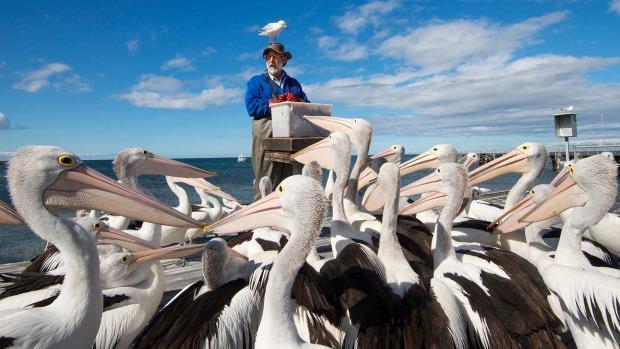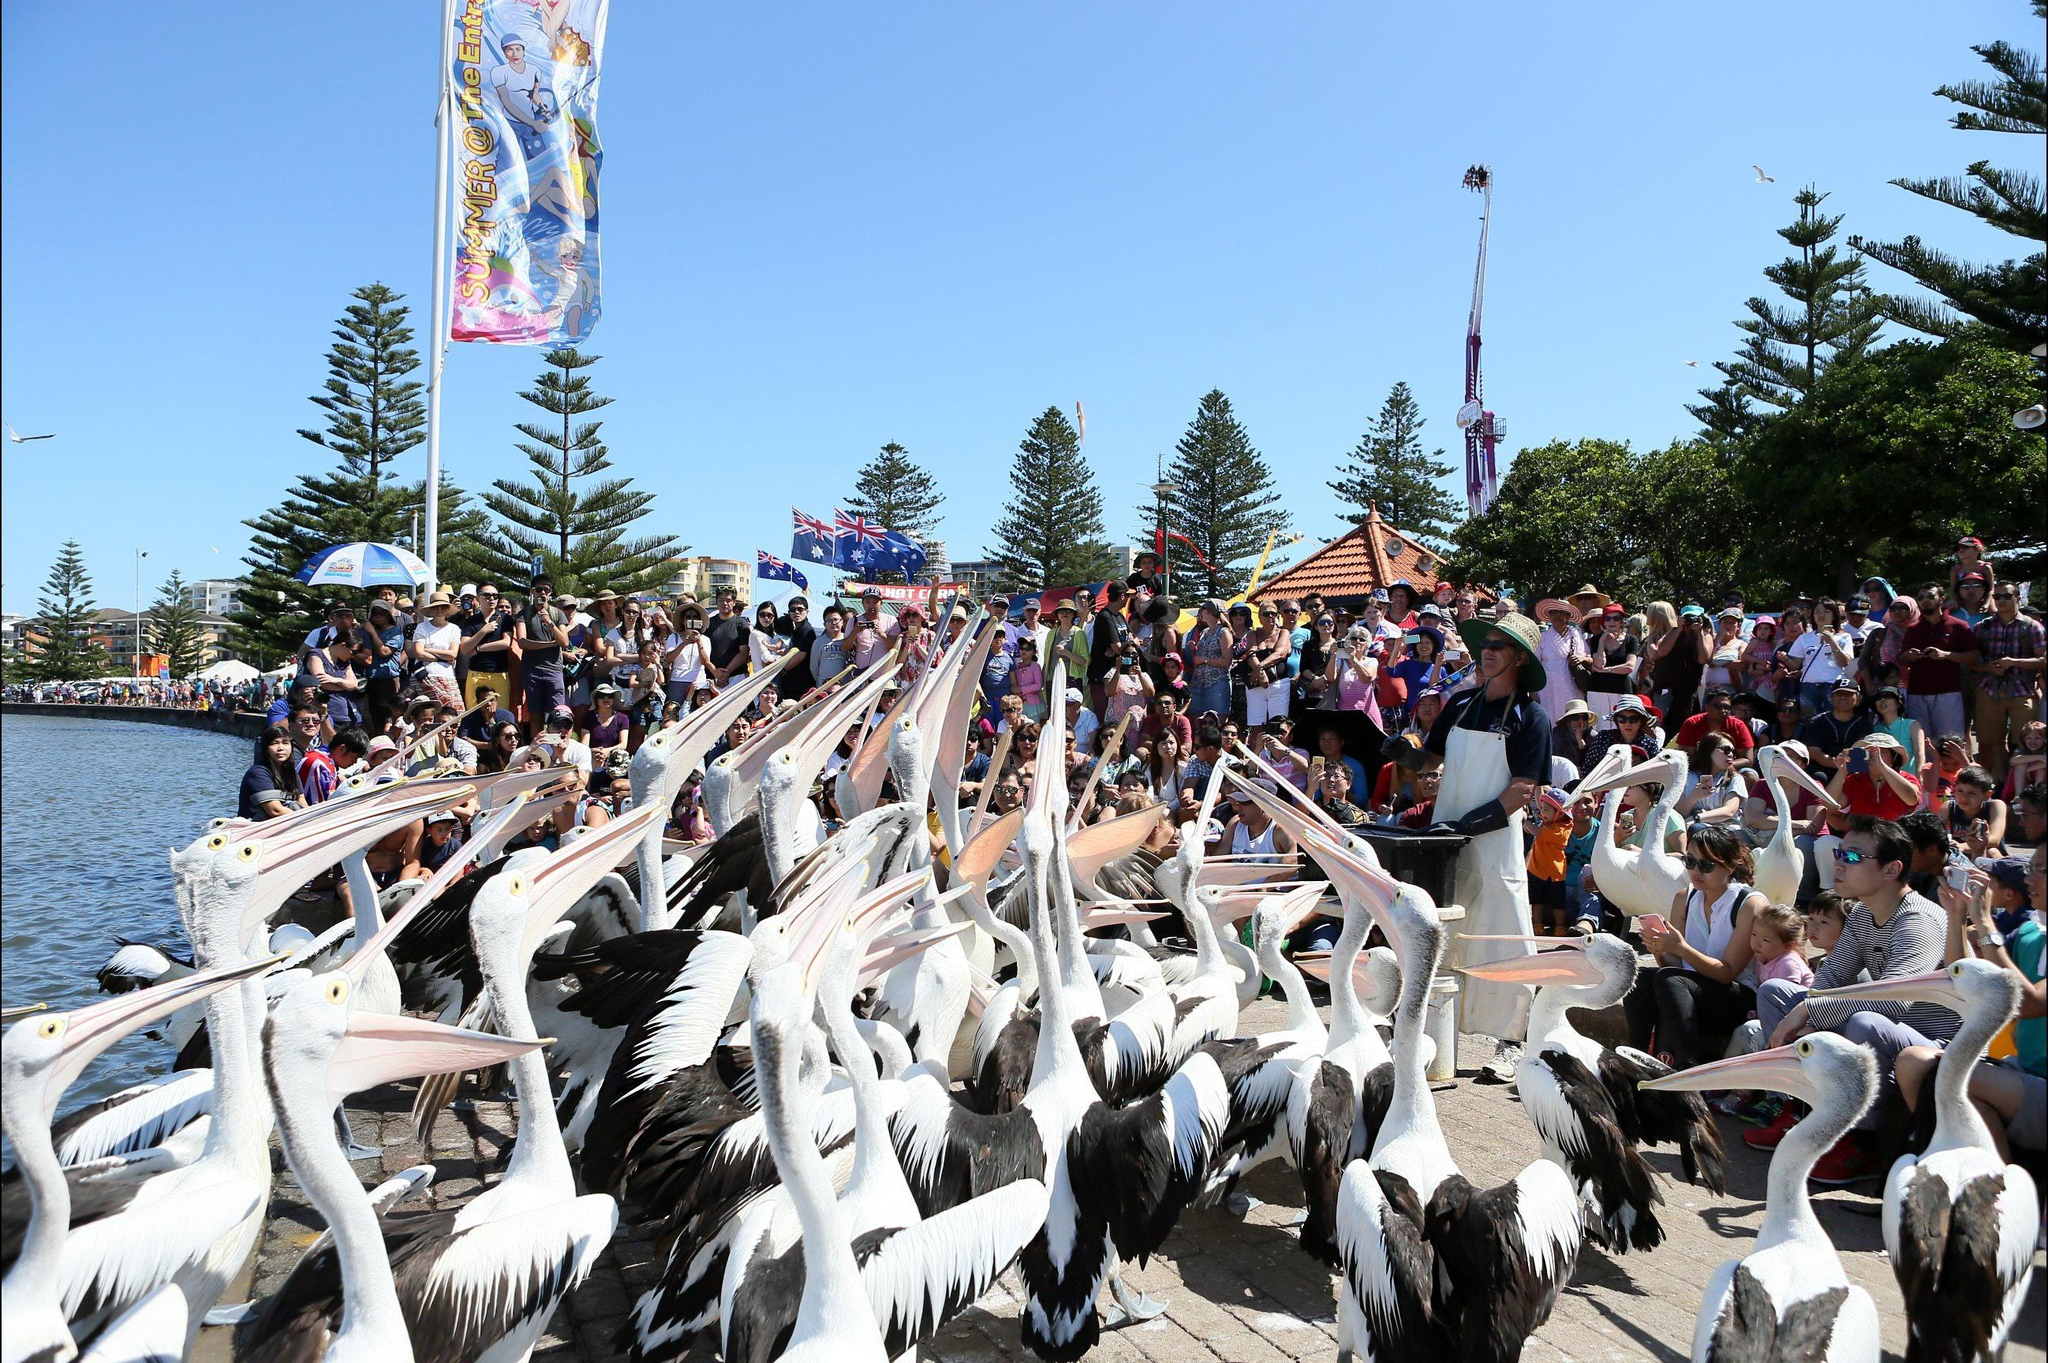The first image is the image on the left, the second image is the image on the right. Evaluate the accuracy of this statement regarding the images: "There is a man wearing a blue jacket in the center of the image.". Is it true? Answer yes or no. Yes. The first image is the image on the left, the second image is the image on the right. Assess this claim about the two images: "There is a red bucket surrounded by many pelicans.". Correct or not? Answer yes or no. No. 